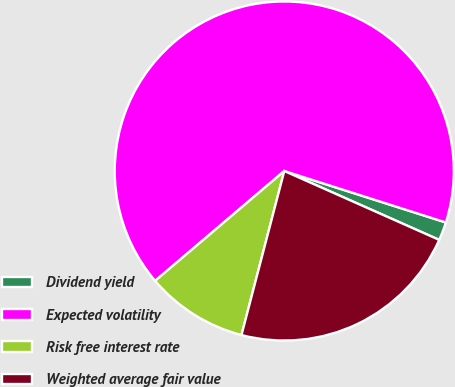Convert chart to OTSL. <chart><loc_0><loc_0><loc_500><loc_500><pie_chart><fcel>Dividend yield<fcel>Expected volatility<fcel>Risk free interest rate<fcel>Weighted average fair value<nl><fcel>1.75%<fcel>66.12%<fcel>9.72%<fcel>22.4%<nl></chart> 